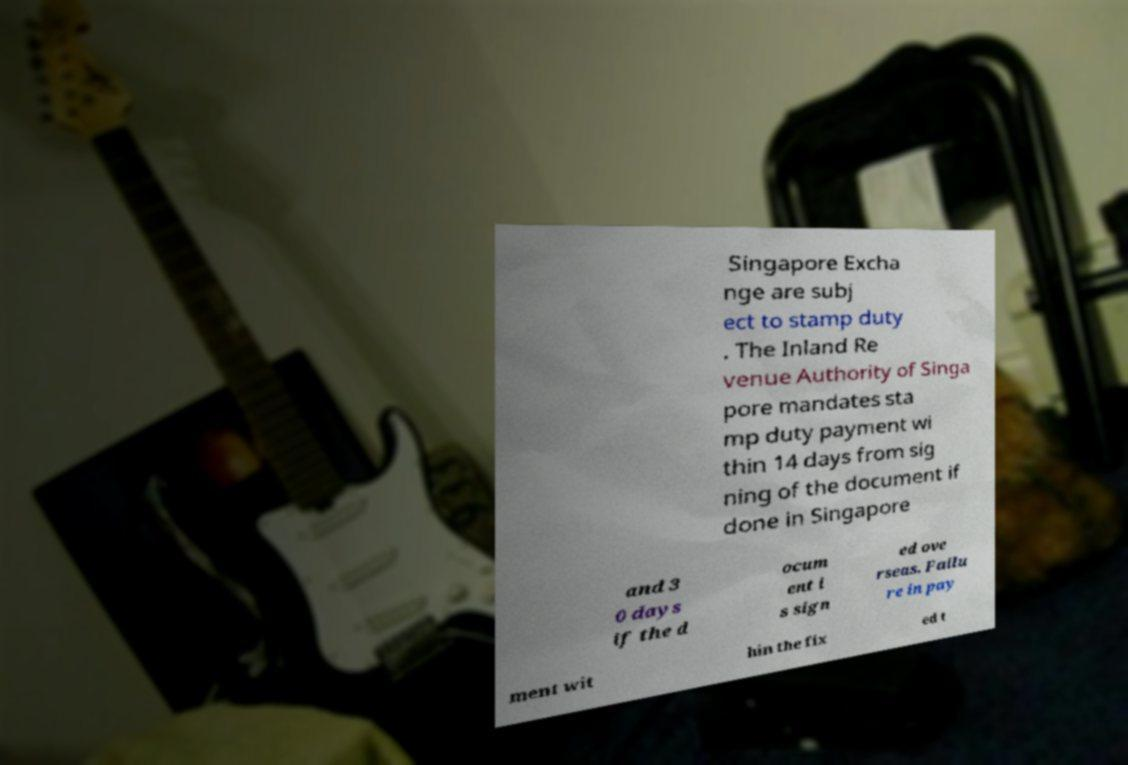Please identify and transcribe the text found in this image. Singapore Excha nge are subj ect to stamp duty . The Inland Re venue Authority of Singa pore mandates sta mp duty payment wi thin 14 days from sig ning of the document if done in Singapore and 3 0 days if the d ocum ent i s sign ed ove rseas. Failu re in pay ment wit hin the fix ed t 